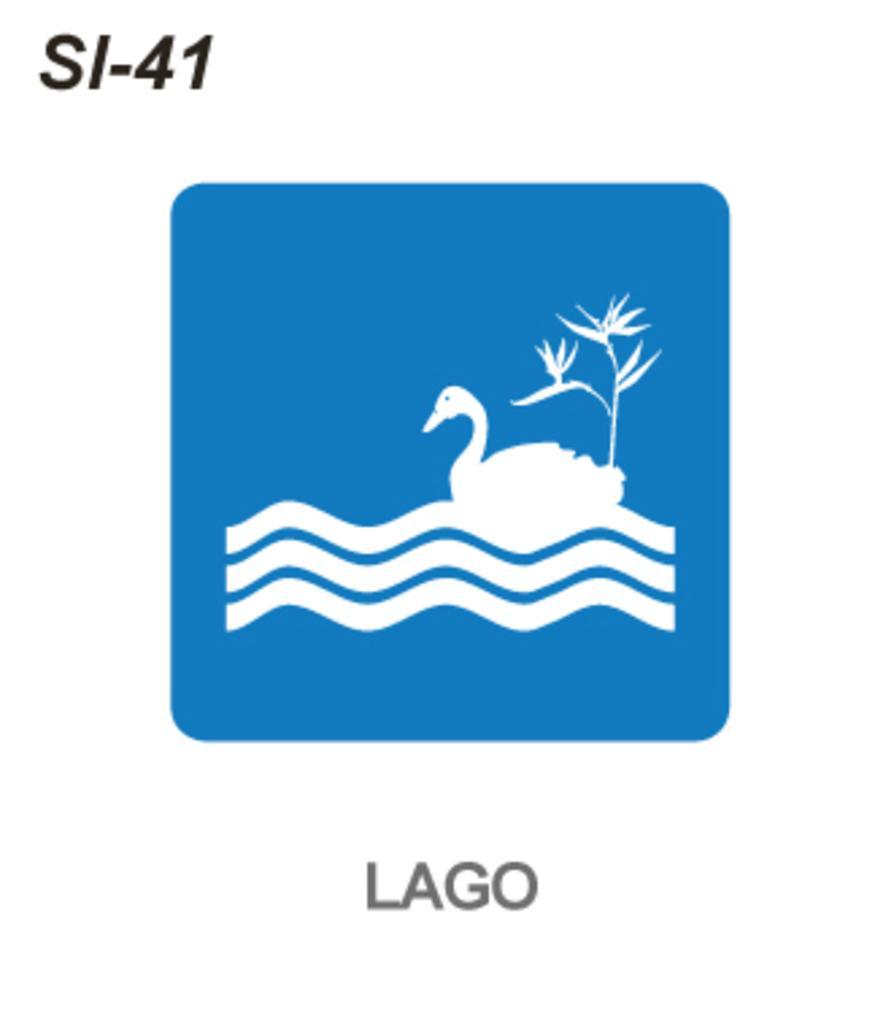Describe this image in one or two sentences. In this picture we can see a logo. 